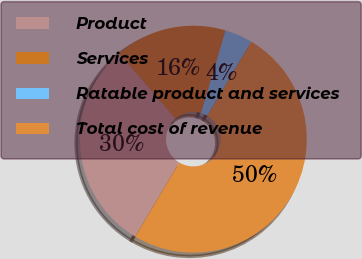Convert chart to OTSL. <chart><loc_0><loc_0><loc_500><loc_500><pie_chart><fcel>Product<fcel>Services<fcel>Ratable product and services<fcel>Total cost of revenue<nl><fcel>30.13%<fcel>15.91%<fcel>3.96%<fcel>50.0%<nl></chart> 